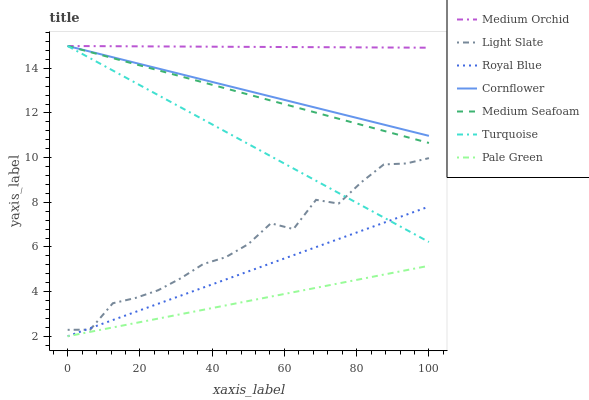Does Pale Green have the minimum area under the curve?
Answer yes or no. Yes. Does Medium Orchid have the maximum area under the curve?
Answer yes or no. Yes. Does Turquoise have the minimum area under the curve?
Answer yes or no. No. Does Turquoise have the maximum area under the curve?
Answer yes or no. No. Is Turquoise the smoothest?
Answer yes or no. Yes. Is Light Slate the roughest?
Answer yes or no. Yes. Is Light Slate the smoothest?
Answer yes or no. No. Is Turquoise the roughest?
Answer yes or no. No. Does Royal Blue have the lowest value?
Answer yes or no. Yes. Does Turquoise have the lowest value?
Answer yes or no. No. Does Medium Seafoam have the highest value?
Answer yes or no. Yes. Does Light Slate have the highest value?
Answer yes or no. No. Is Light Slate less than Medium Orchid?
Answer yes or no. Yes. Is Medium Seafoam greater than Light Slate?
Answer yes or no. Yes. Does Cornflower intersect Medium Seafoam?
Answer yes or no. Yes. Is Cornflower less than Medium Seafoam?
Answer yes or no. No. Is Cornflower greater than Medium Seafoam?
Answer yes or no. No. Does Light Slate intersect Medium Orchid?
Answer yes or no. No. 